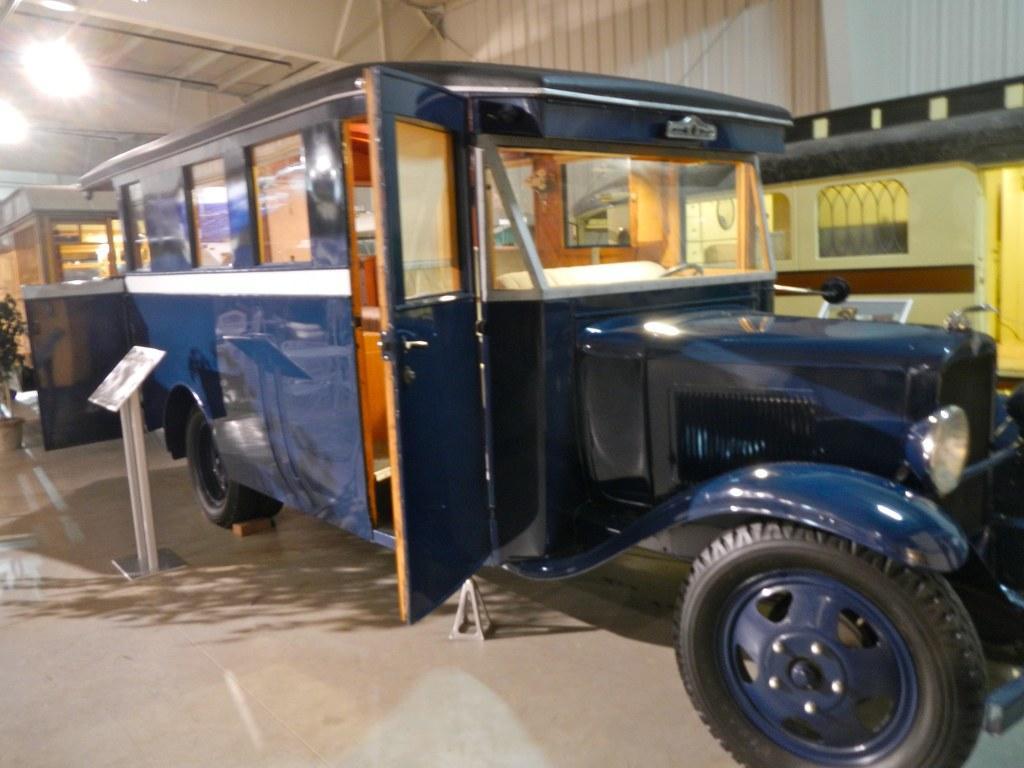Describe this image in one or two sentences. In this picture there is a vehicle which is in blue color whose door is kept opened and there is a stand beside it and there is a plant in the left corner and there are few lights and some other objects in the background. 